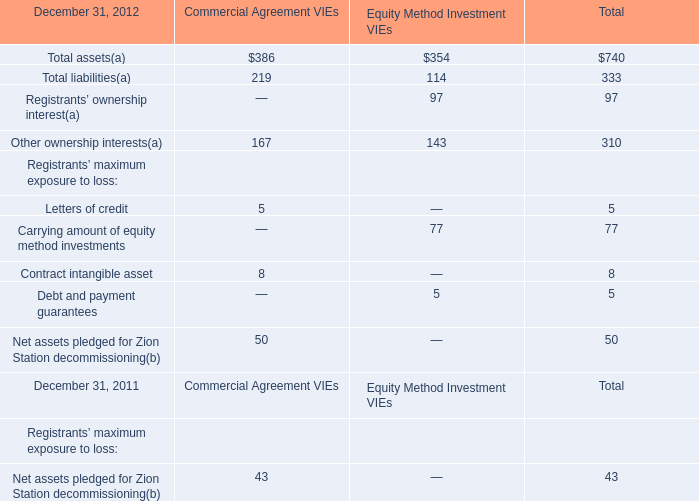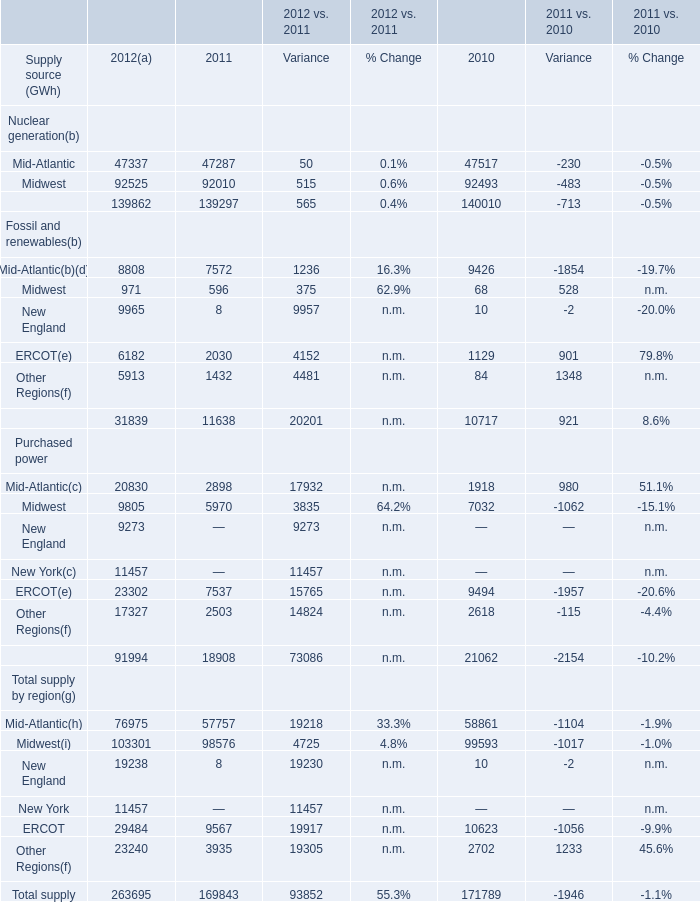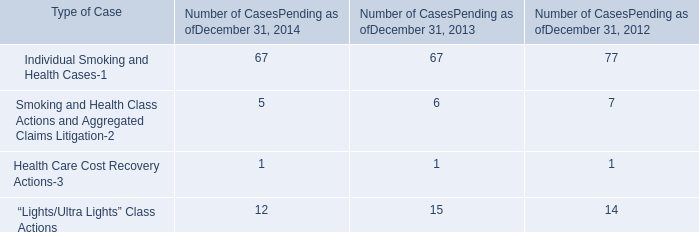What's the current growth rate of Supply from Fossil and renewables? 
Computations: ((31839 - 11638) / 11638)
Answer: 1.73578. 